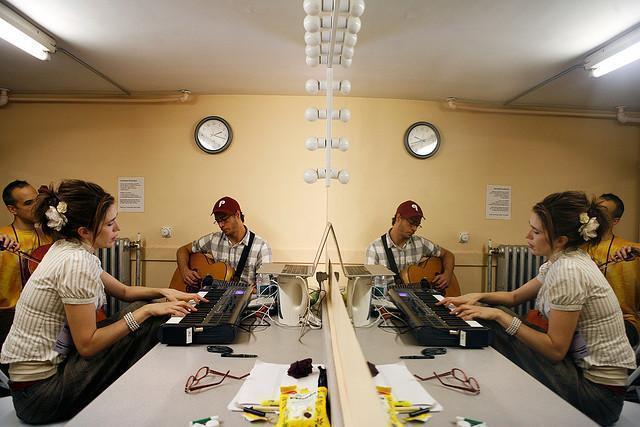At least how many musicians play different instruments here?
Make your selection and explain in format: 'Answer: answer
Rationale: rationale.'
Options: Two, eight, one, three. Answer: three.
Rationale: The mirror makes it look like there are more 